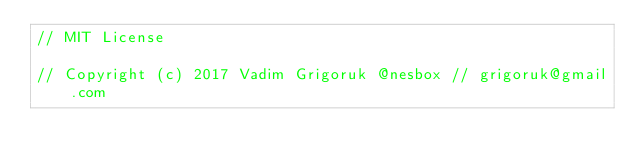<code> <loc_0><loc_0><loc_500><loc_500><_C_>// MIT License

// Copyright (c) 2017 Vadim Grigoruk @nesbox // grigoruk@gmail.com
</code> 